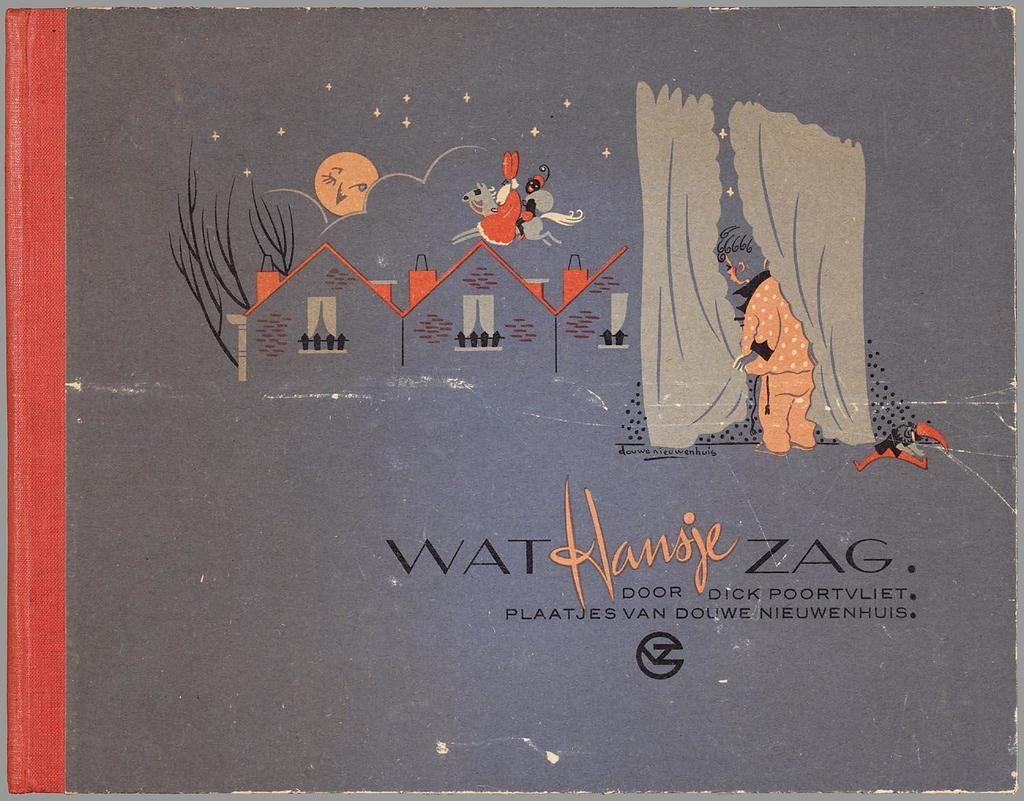What object is present in the image? There is a book in the image. What can be found on the book? The book has text and cartoon images on it. How many trucks are depicted on the book's cover? There is no mention of trucks in the image or the provided facts, so we cannot determine the number of trucks depicted on the book's cover. 